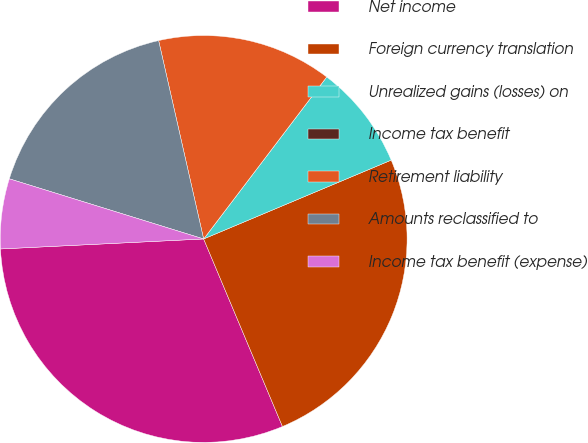<chart> <loc_0><loc_0><loc_500><loc_500><pie_chart><fcel>Net income<fcel>Foreign currency translation<fcel>Unrealized gains (losses) on<fcel>Income tax benefit<fcel>Retirement liability<fcel>Amounts reclassified to<fcel>Income tax benefit (expense)<nl><fcel>30.55%<fcel>25.0%<fcel>8.33%<fcel>0.0%<fcel>13.89%<fcel>16.67%<fcel>5.56%<nl></chart> 